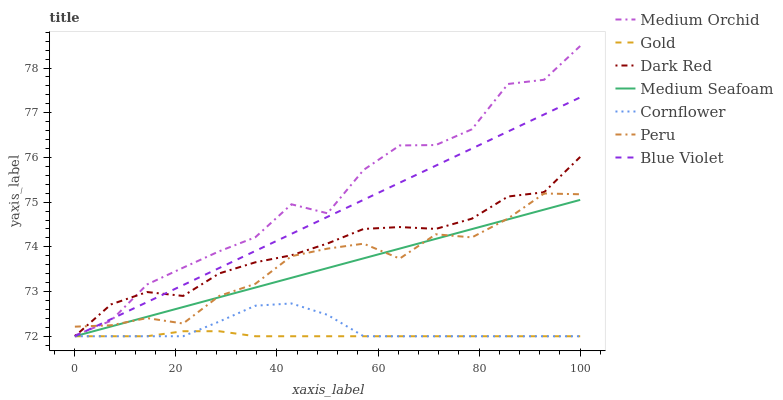Does Gold have the minimum area under the curve?
Answer yes or no. Yes. Does Medium Orchid have the maximum area under the curve?
Answer yes or no. Yes. Does Dark Red have the minimum area under the curve?
Answer yes or no. No. Does Dark Red have the maximum area under the curve?
Answer yes or no. No. Is Blue Violet the smoothest?
Answer yes or no. Yes. Is Medium Orchid the roughest?
Answer yes or no. Yes. Is Gold the smoothest?
Answer yes or no. No. Is Gold the roughest?
Answer yes or no. No. Does Cornflower have the lowest value?
Answer yes or no. Yes. Does Medium Orchid have the lowest value?
Answer yes or no. No. Does Medium Orchid have the highest value?
Answer yes or no. Yes. Does Dark Red have the highest value?
Answer yes or no. No. Is Cornflower less than Peru?
Answer yes or no. Yes. Is Medium Orchid greater than Cornflower?
Answer yes or no. Yes. Does Cornflower intersect Dark Red?
Answer yes or no. Yes. Is Cornflower less than Dark Red?
Answer yes or no. No. Is Cornflower greater than Dark Red?
Answer yes or no. No. Does Cornflower intersect Peru?
Answer yes or no. No. 